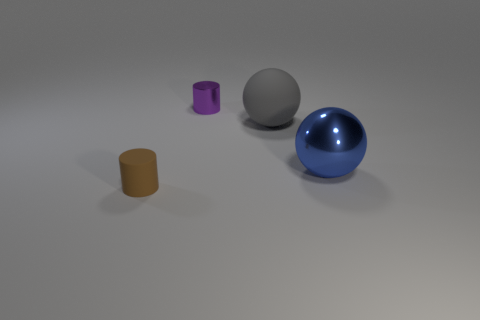Is the size of the gray matte ball the same as the metal object that is left of the gray thing?
Your response must be concise. No. There is a small object that is in front of the cylinder that is to the right of the brown matte cylinder; what is it made of?
Keep it short and to the point. Rubber. Are there an equal number of large gray spheres that are right of the big metal thing and large yellow metallic spheres?
Make the answer very short. Yes. There is a object that is both left of the big gray matte thing and in front of the big gray matte thing; how big is it?
Your answer should be compact. Small. There is a tiny cylinder in front of the big thing right of the gray matte sphere; what is its color?
Your answer should be very brief. Brown. What number of cyan objects are either rubber spheres or small metal cylinders?
Offer a very short reply. 0. There is a thing that is both in front of the gray object and on the right side of the rubber cylinder; what is its color?
Provide a short and direct response. Blue. How many tiny things are gray metal cubes or blue metal balls?
Provide a succinct answer. 0. There is another object that is the same shape as the tiny metallic thing; what size is it?
Your answer should be compact. Small. What shape is the blue metal thing?
Ensure brevity in your answer.  Sphere. 